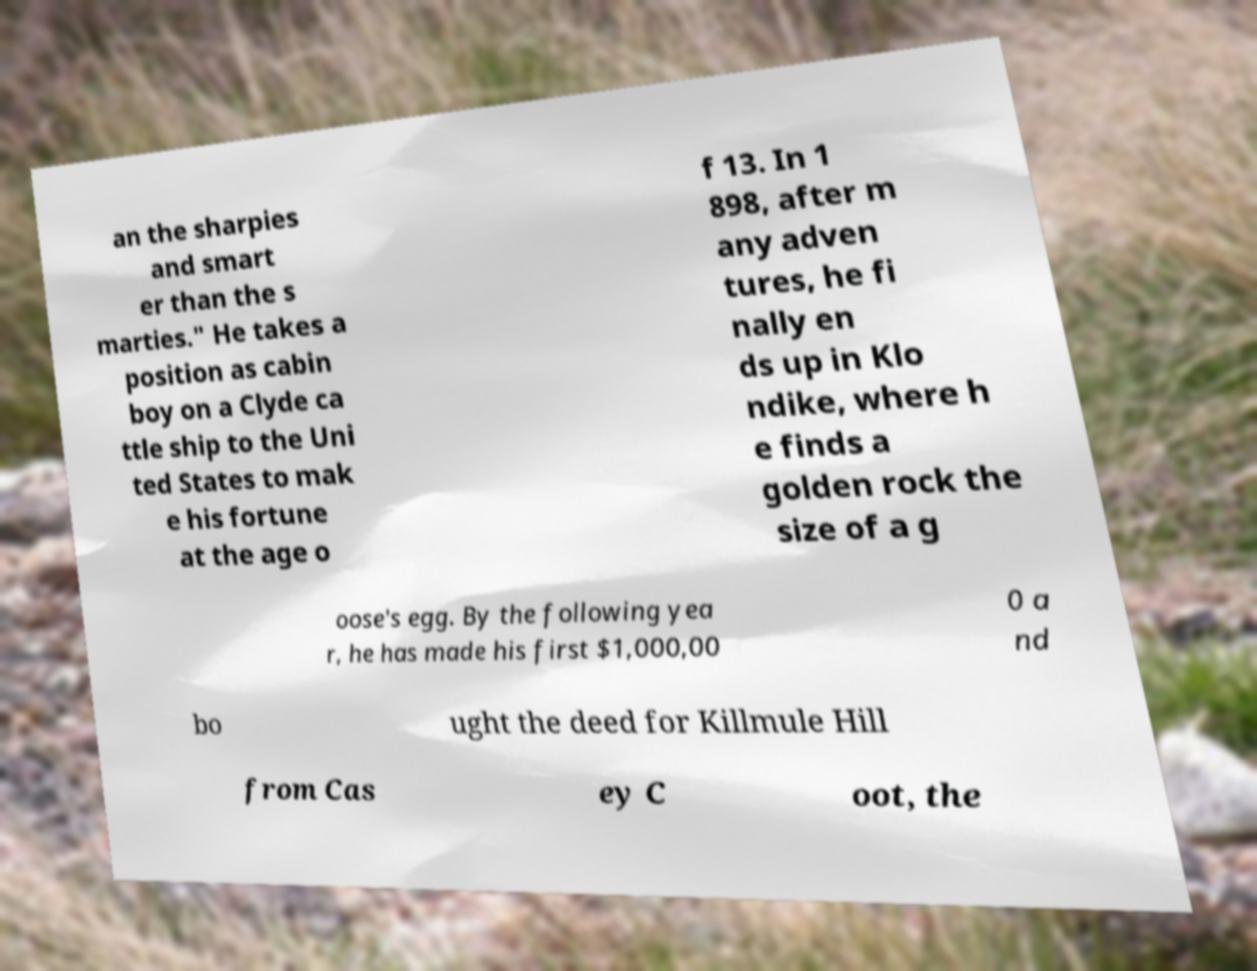Can you accurately transcribe the text from the provided image for me? an the sharpies and smart er than the s marties." He takes a position as cabin boy on a Clyde ca ttle ship to the Uni ted States to mak e his fortune at the age o f 13. In 1 898, after m any adven tures, he fi nally en ds up in Klo ndike, where h e finds a golden rock the size of a g oose's egg. By the following yea r, he has made his first $1,000,00 0 a nd bo ught the deed for Killmule Hill from Cas ey C oot, the 